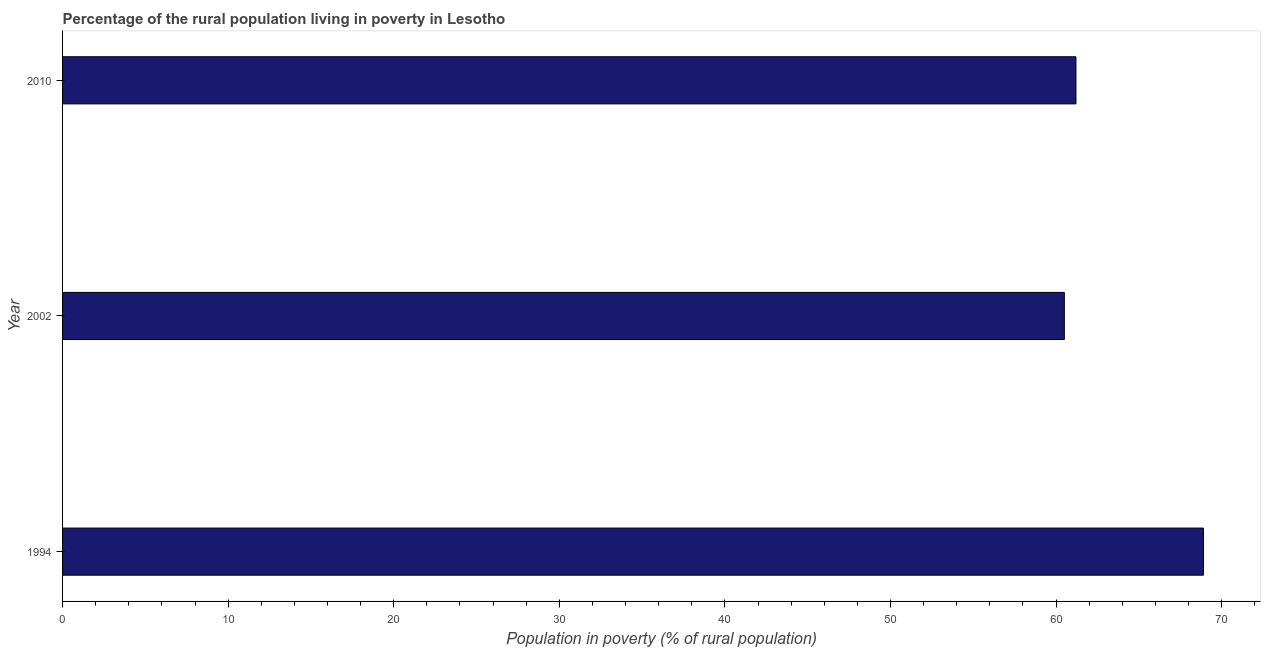Does the graph contain any zero values?
Ensure brevity in your answer.  No. What is the title of the graph?
Give a very brief answer. Percentage of the rural population living in poverty in Lesotho. What is the label or title of the X-axis?
Give a very brief answer. Population in poverty (% of rural population). What is the label or title of the Y-axis?
Offer a terse response. Year. What is the percentage of rural population living below poverty line in 2002?
Your answer should be very brief. 60.5. Across all years, what is the maximum percentage of rural population living below poverty line?
Your answer should be compact. 68.9. Across all years, what is the minimum percentage of rural population living below poverty line?
Offer a very short reply. 60.5. What is the sum of the percentage of rural population living below poverty line?
Provide a succinct answer. 190.6. What is the average percentage of rural population living below poverty line per year?
Offer a terse response. 63.53. What is the median percentage of rural population living below poverty line?
Make the answer very short. 61.2. What is the ratio of the percentage of rural population living below poverty line in 1994 to that in 2010?
Make the answer very short. 1.13. What is the difference between the highest and the second highest percentage of rural population living below poverty line?
Ensure brevity in your answer.  7.7. Is the sum of the percentage of rural population living below poverty line in 2002 and 2010 greater than the maximum percentage of rural population living below poverty line across all years?
Your response must be concise. Yes. How many bars are there?
Make the answer very short. 3. Are all the bars in the graph horizontal?
Your answer should be very brief. Yes. How many years are there in the graph?
Keep it short and to the point. 3. What is the Population in poverty (% of rural population) of 1994?
Keep it short and to the point. 68.9. What is the Population in poverty (% of rural population) in 2002?
Your answer should be compact. 60.5. What is the Population in poverty (% of rural population) of 2010?
Give a very brief answer. 61.2. What is the ratio of the Population in poverty (% of rural population) in 1994 to that in 2002?
Give a very brief answer. 1.14. What is the ratio of the Population in poverty (% of rural population) in 1994 to that in 2010?
Your answer should be very brief. 1.13. 